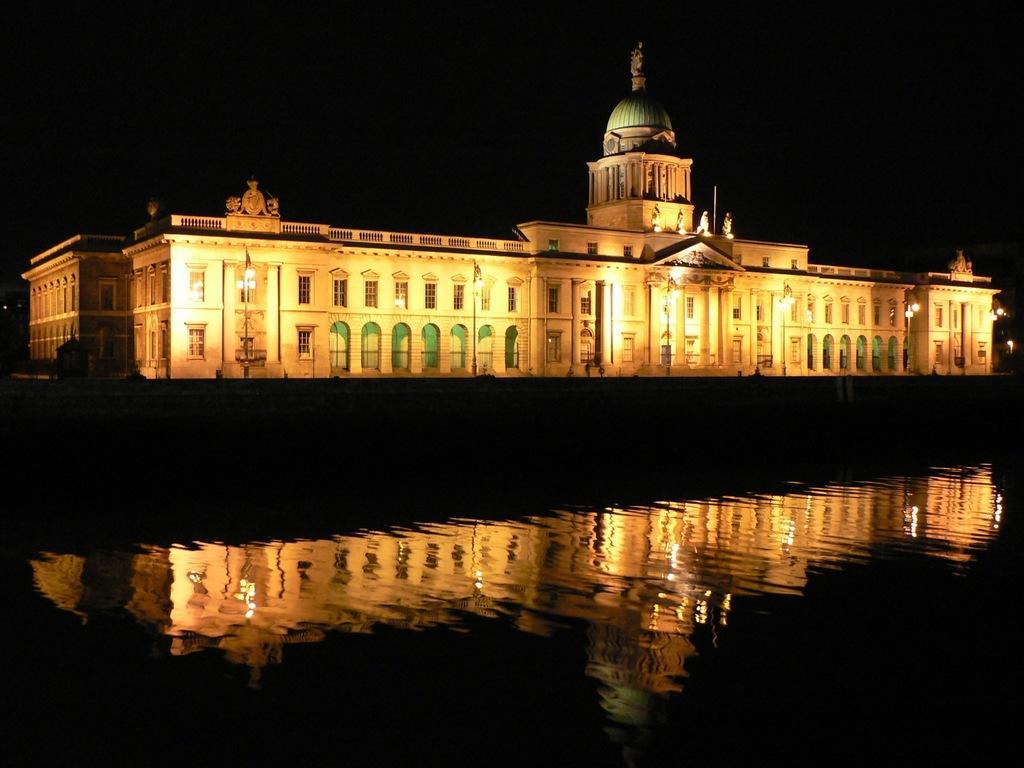Describe this image in one or two sentences. Here we can see a building. To this building there are lights. On this water there is a reflection of this building. 